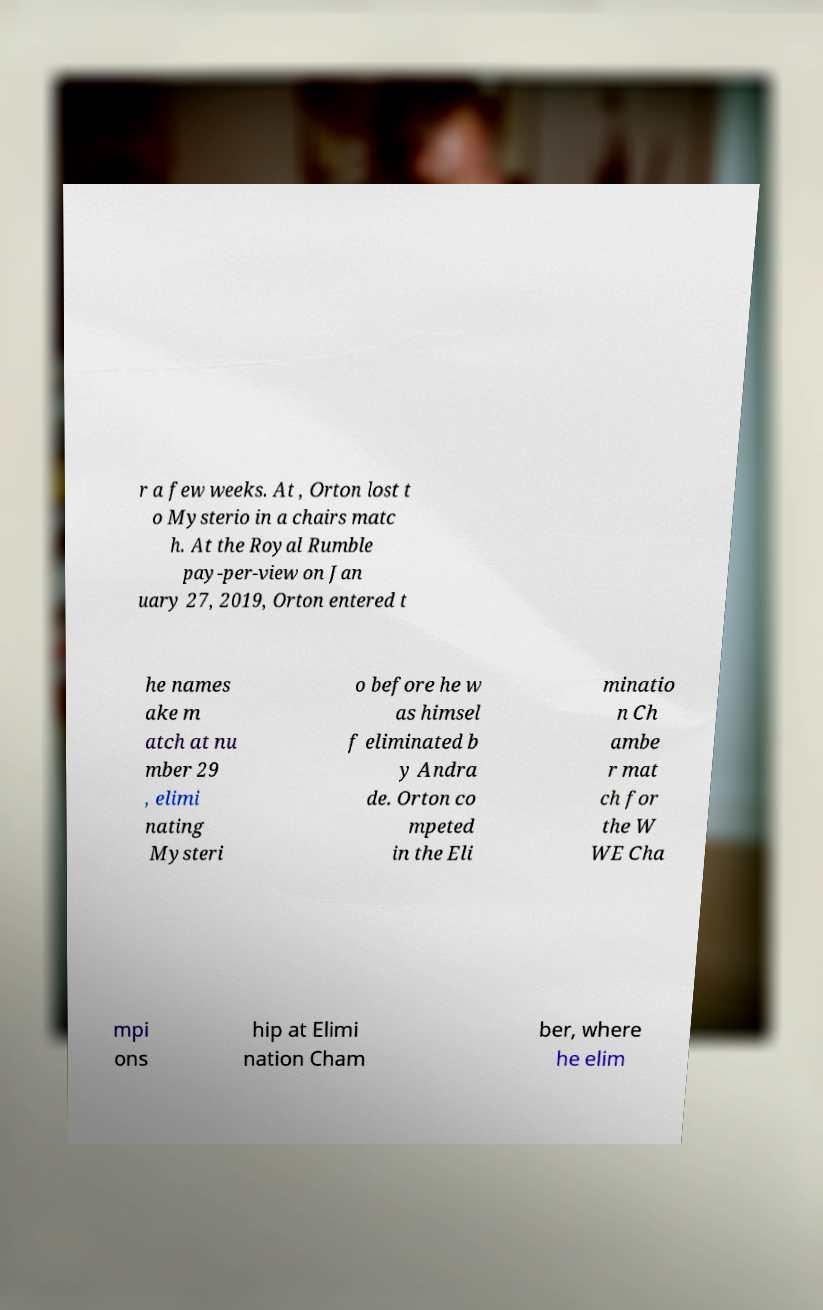I need the written content from this picture converted into text. Can you do that? r a few weeks. At , Orton lost t o Mysterio in a chairs matc h. At the Royal Rumble pay-per-view on Jan uary 27, 2019, Orton entered t he names ake m atch at nu mber 29 , elimi nating Mysteri o before he w as himsel f eliminated b y Andra de. Orton co mpeted in the Eli minatio n Ch ambe r mat ch for the W WE Cha mpi ons hip at Elimi nation Cham ber, where he elim 